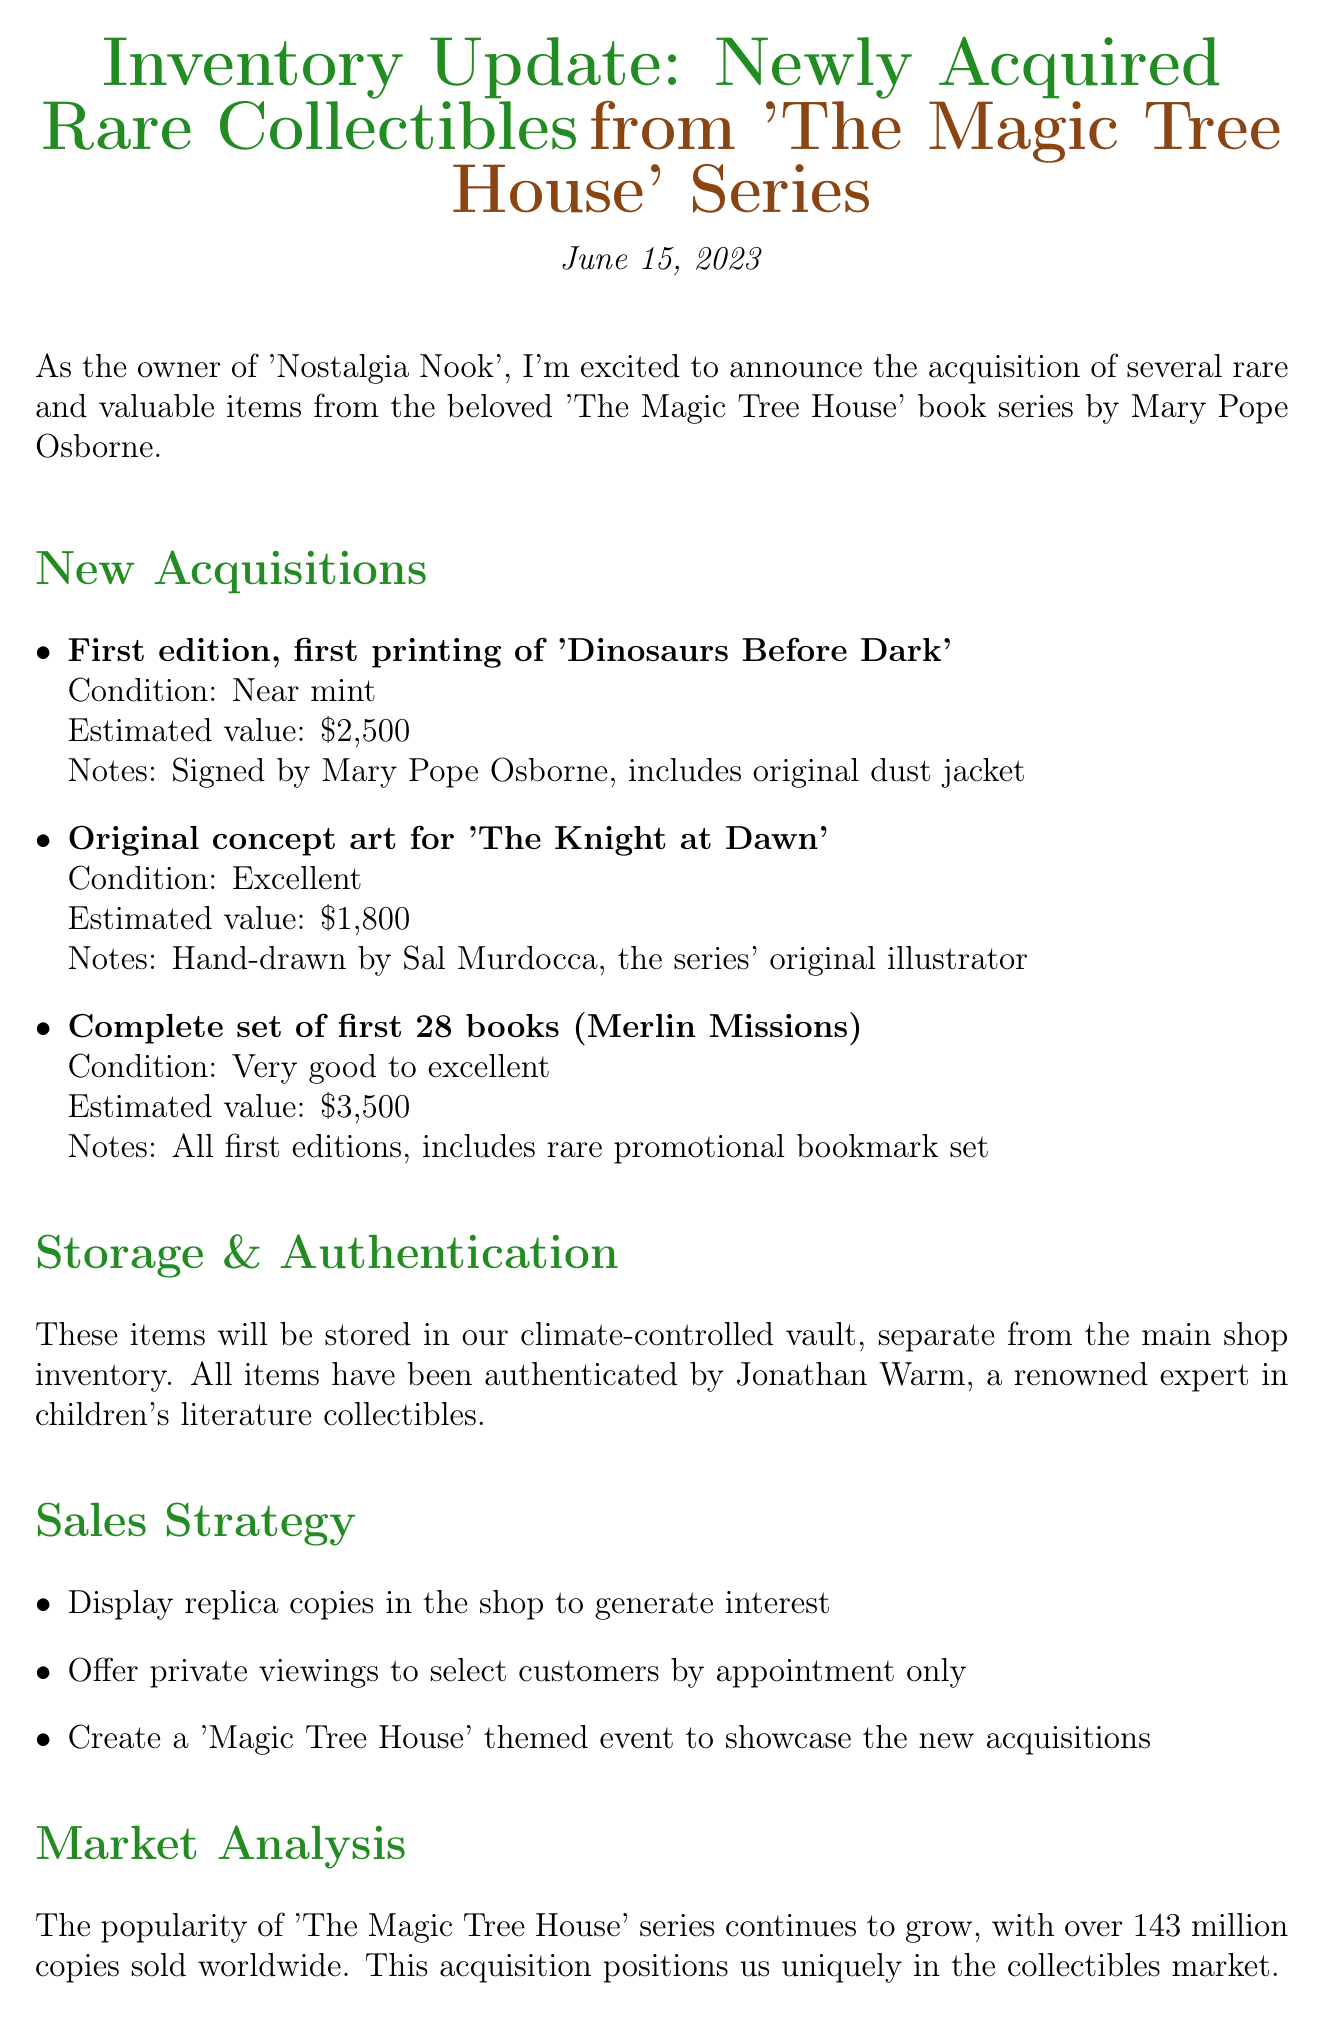What is the date of the memo? The date of the memo is clearly stated at the top of the document.
Answer: June 15, 2023 Who authenticated the newly acquired items? The document mentions Jonathan Warm as the expert who authenticated the items.
Answer: Jonathan Warm What is the estimated value of the first edition of 'Dinosaurs Before Dark'? The estimated value is listed under the new acquisitions section for this item.
Answer: $2,500 How many books are in the complete set of first 28 books (Merlin Missions)? The set description includes the number of books in the title.
Answer: 28 What is the total investment for the new acquisitions? The total investment is specified in the financial implications section of the memo.
Answer: $12,500 What is the projected return on investment? The projected return is mentioned in the financial implications section and requires basic comprehension.
Answer: 25-30% In what condition is the original concept art for 'The Knight at Dawn'? The condition is explicitly described in the details about the item.
Answer: Excellent What is the storage location for the newly acquired items? The document specifies where the items will be kept in the storage section.
Answer: Climate-controlled vault 